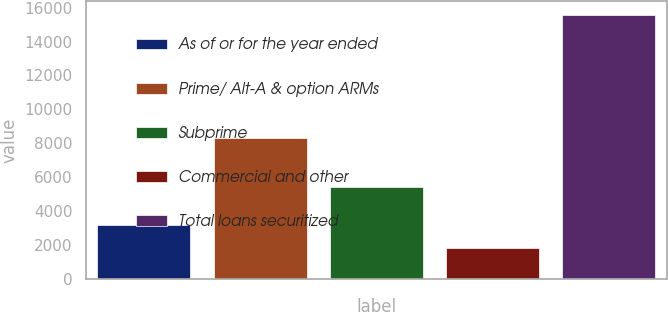Convert chart to OTSL. <chart><loc_0><loc_0><loc_500><loc_500><bar_chart><fcel>As of or for the year ended<fcel>Prime/ Alt-A & option ARMs<fcel>Subprime<fcel>Commercial and other<fcel>Total loans securitized<nl><fcel>3185.3<fcel>8325<fcel>5448<fcel>1808<fcel>15581<nl></chart> 